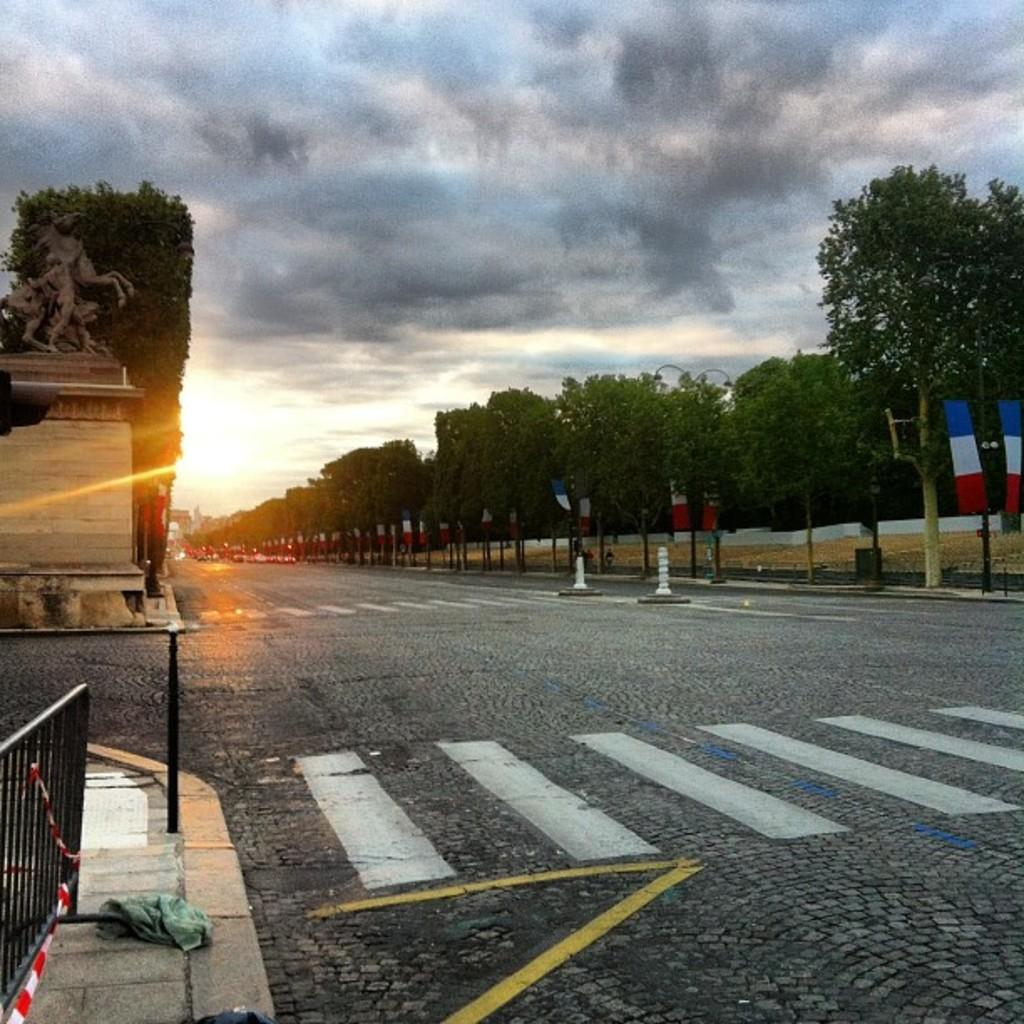What is the main feature of the image? There is a road in the image. What can be seen on the road? White lines are present on the road are present. What type of vegetation is visible in the image? There are trees in the image. What structures can be seen in the image? There are poles in the image. What type of ground cover is present in the image? There is grass in the image. What type of barrier is visible in the image? There is a fence in the image. What is the weather like in the image? The sky is visible in the image and appears cloudy. What additional feature can be seen in the image? There is a sculpture in the image. What celestial body is visible in the image? The sun is visible in the image. Where is the hydrant located in the image? There is no hydrant present in the image. What type of stove can be seen in the image? There is no stove present in the image. 